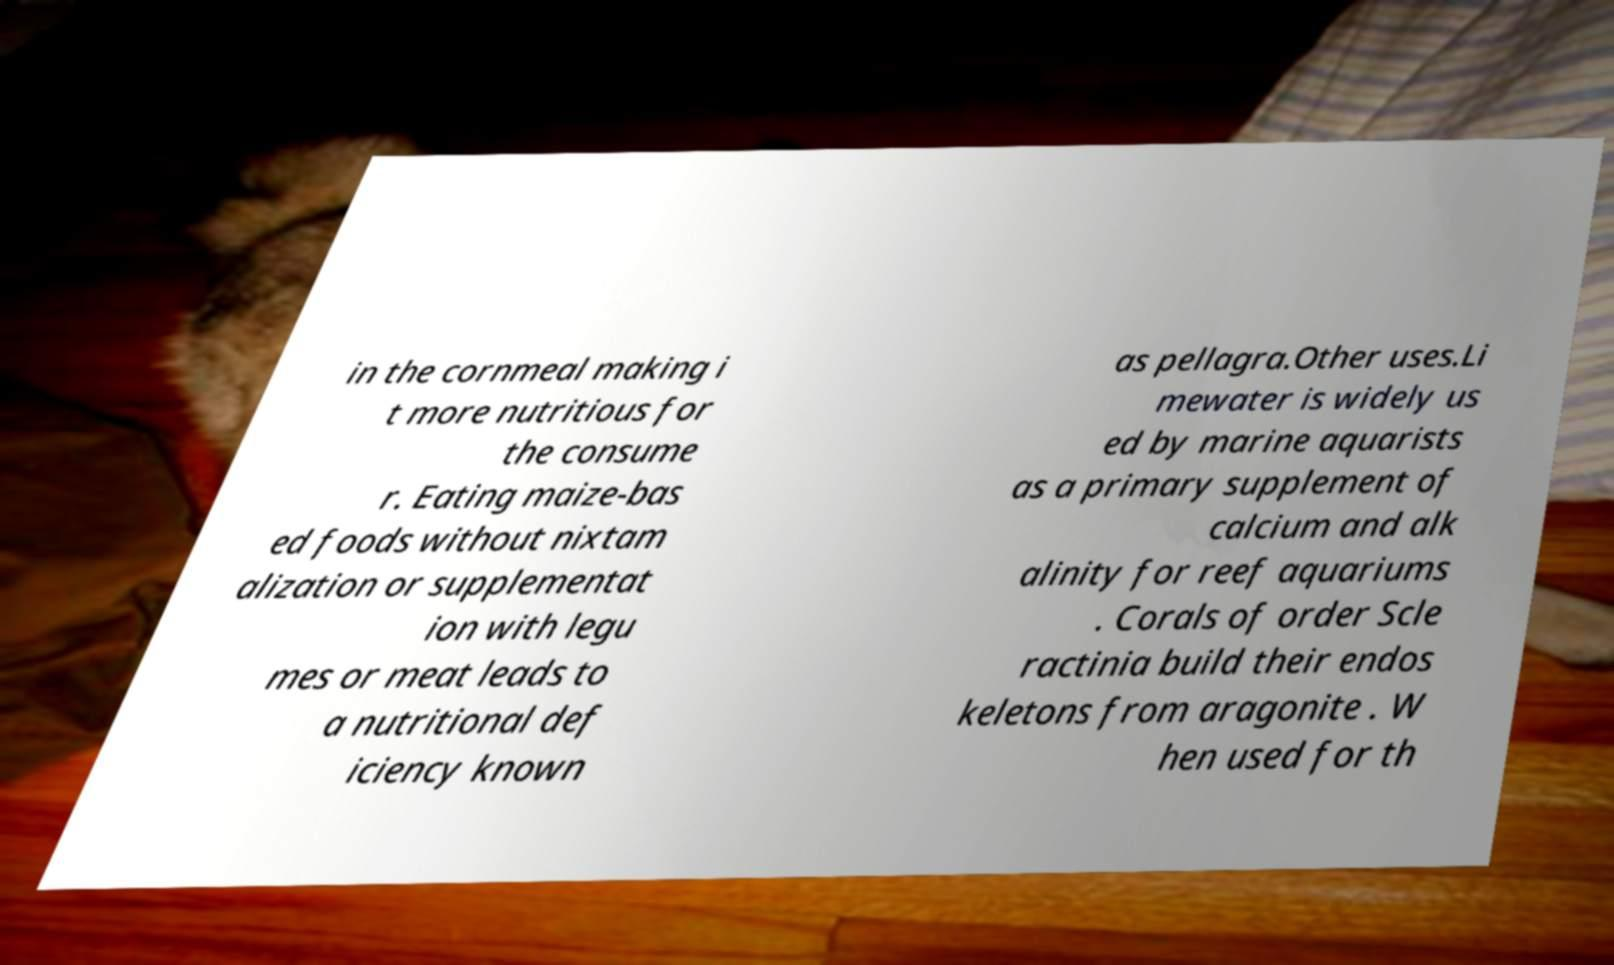I need the written content from this picture converted into text. Can you do that? in the cornmeal making i t more nutritious for the consume r. Eating maize-bas ed foods without nixtam alization or supplementat ion with legu mes or meat leads to a nutritional def iciency known as pellagra.Other uses.Li mewater is widely us ed by marine aquarists as a primary supplement of calcium and alk alinity for reef aquariums . Corals of order Scle ractinia build their endos keletons from aragonite . W hen used for th 